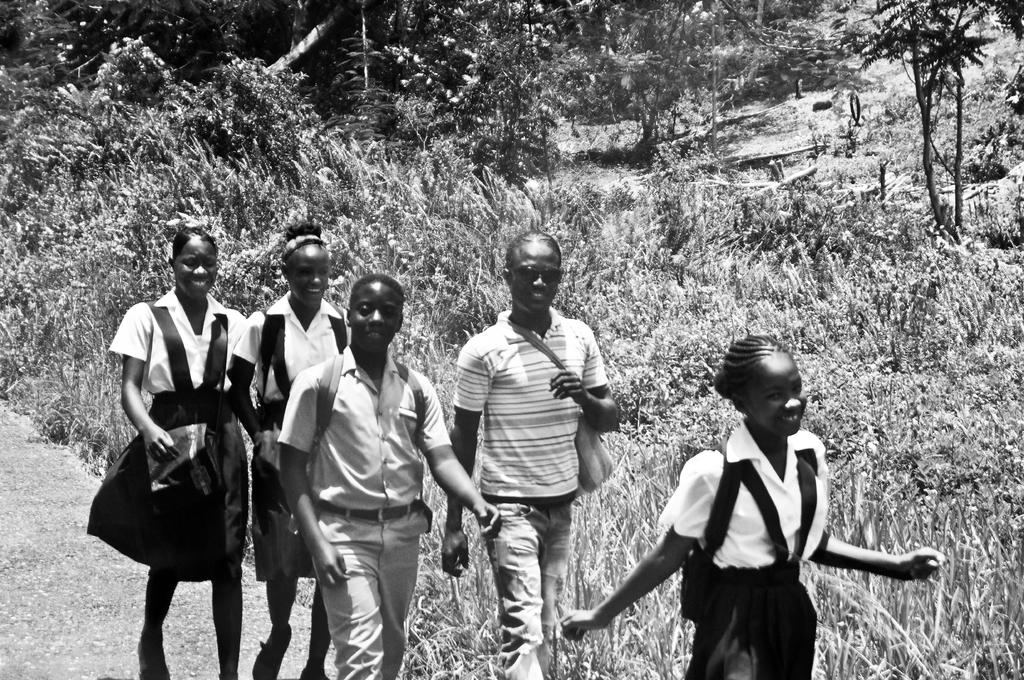Who or what is present in the image? There are people in the image. What are the people doing in the image? The people are walking and smiling. What can be seen in the background of the image? There are plants and trees in the background of the image. What type of berry can be seen growing on the spade in the image? There is no spade or berry present in the image. 